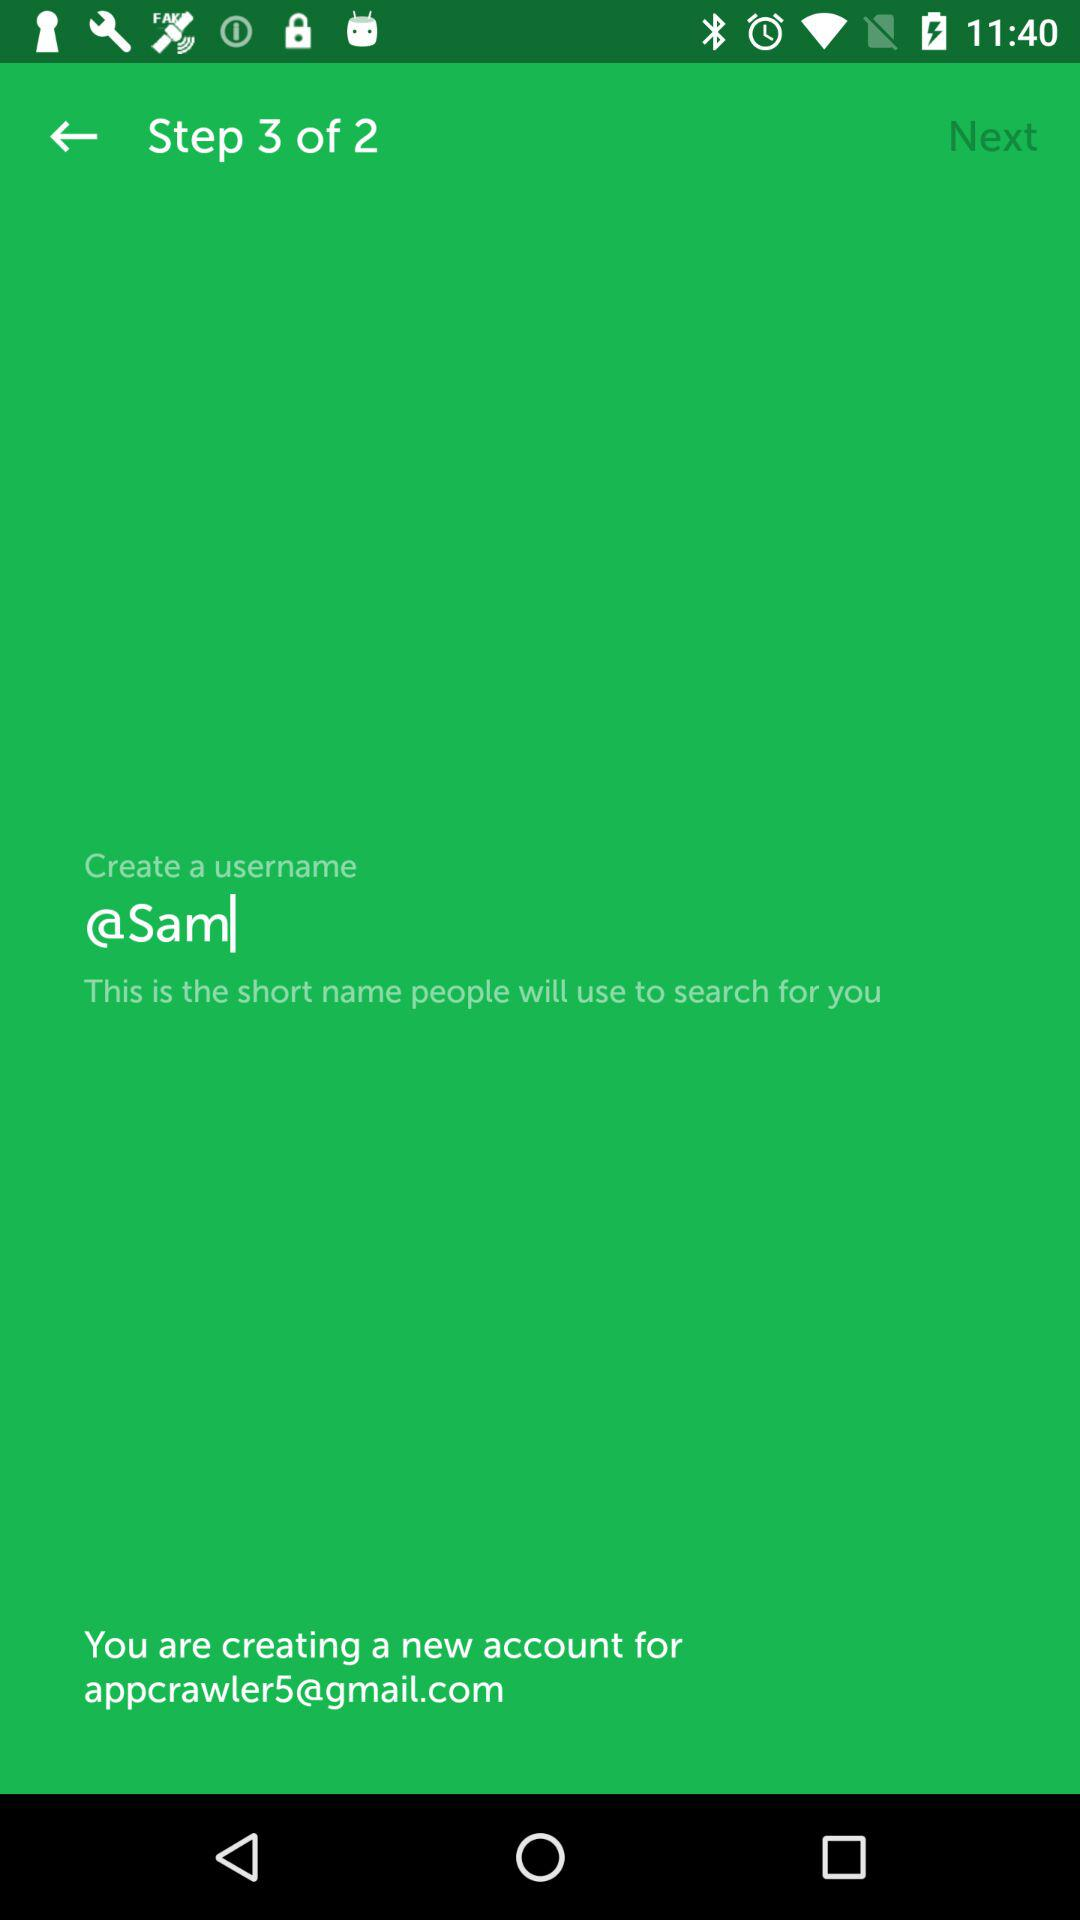What is the new account email address? The email address is appcrawler5@gmail.com. 